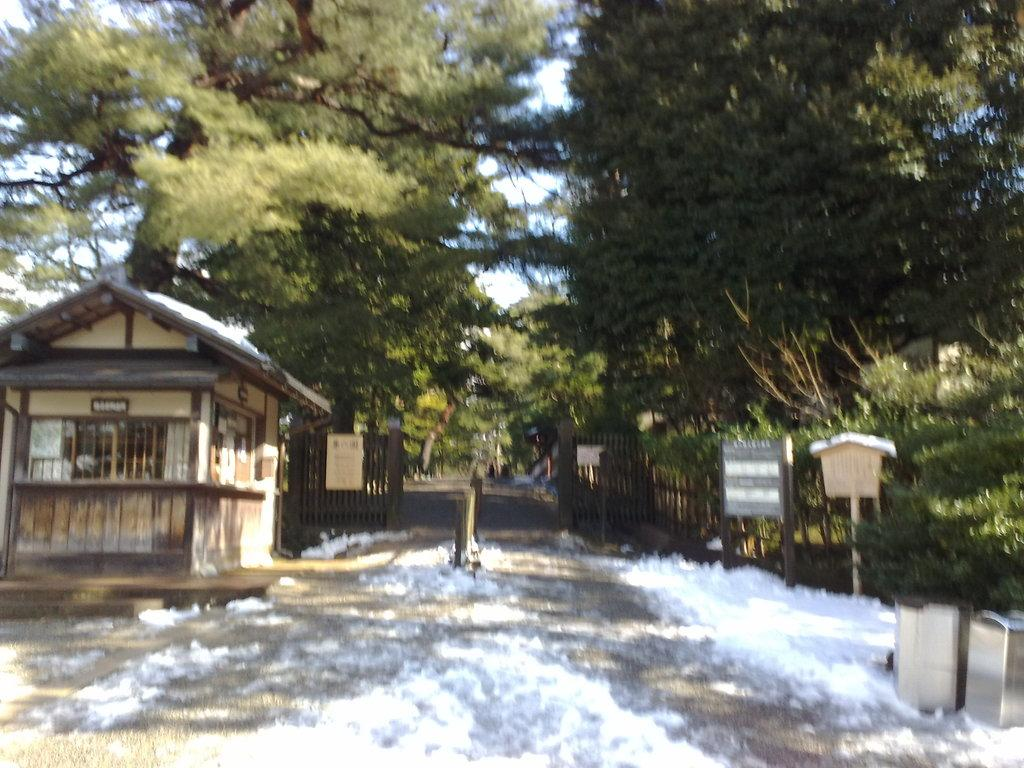What is covering the ground in the image? There is water on the ground in the image. What type of structures can be seen in the image? There are sheds in the image. What is used to separate or enclose areas in the image? There is a fence in the image. What type of signs are present in the image? There are name boards in the image. What else can be seen in the image besides the water, sheds, fence, and name boards? There are objects in the image. What can be seen in the background of the image? There are trees and the sky visible in the background of the image. What month is it in the image? The month cannot be determined from the image, as it does not contain any information about the time of year. What type of leaf is present on the trees in the image? There is no specific leaf type mentioned in the image, as it only states that there are trees in the background. 